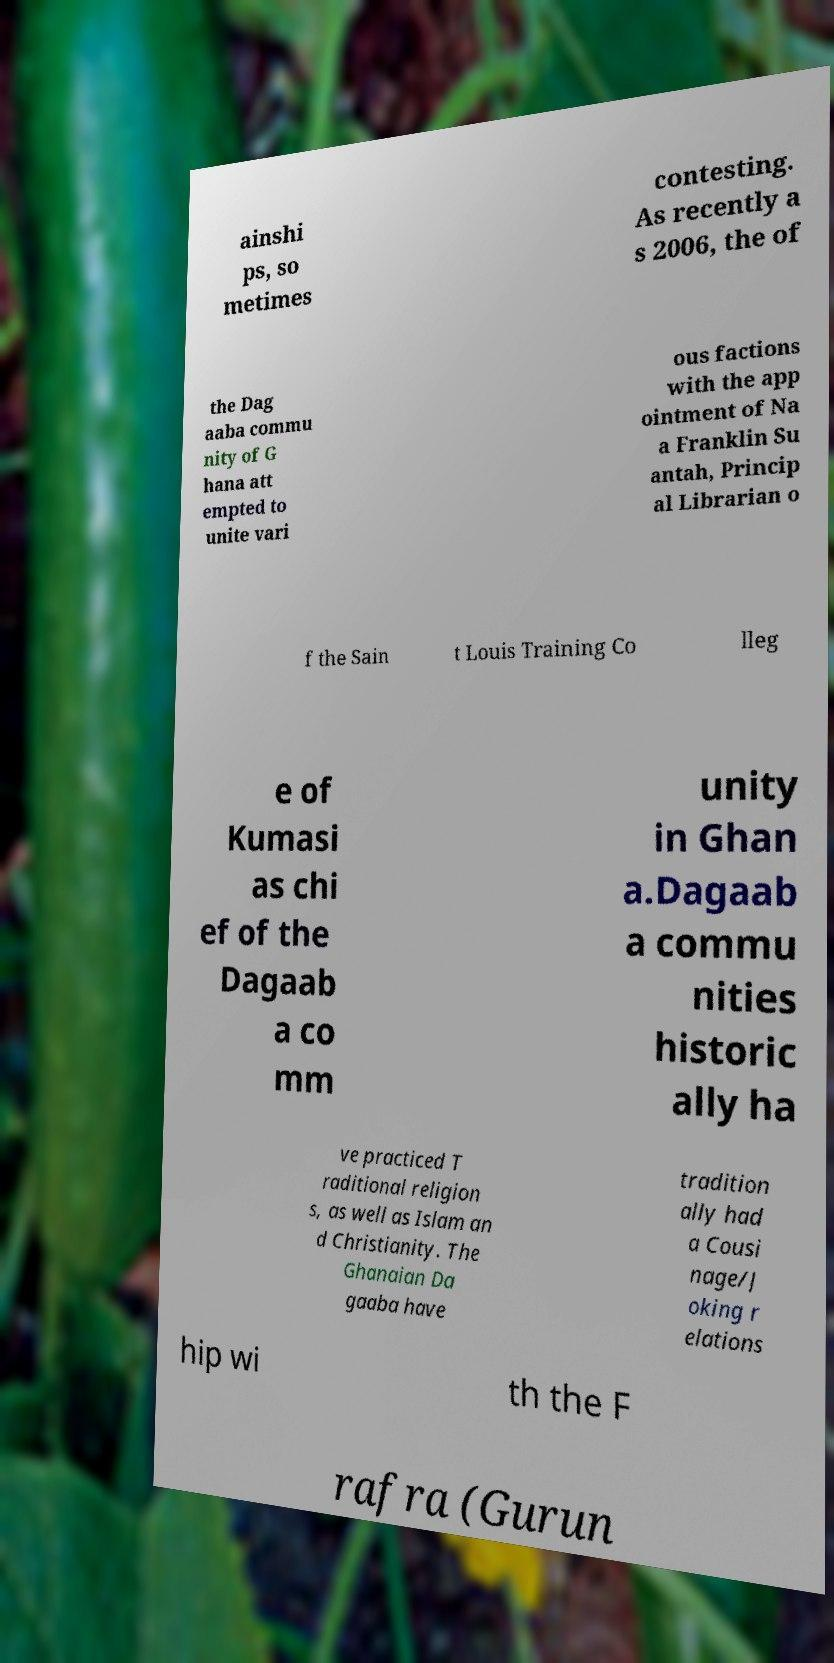Could you assist in decoding the text presented in this image and type it out clearly? ainshi ps, so metimes contesting. As recently a s 2006, the of the Dag aaba commu nity of G hana att empted to unite vari ous factions with the app ointment of Na a Franklin Su antah, Princip al Librarian o f the Sain t Louis Training Co lleg e of Kumasi as chi ef of the Dagaab a co mm unity in Ghan a.Dagaab a commu nities historic ally ha ve practiced T raditional religion s, as well as Islam an d Christianity. The Ghanaian Da gaaba have tradition ally had a Cousi nage/J oking r elations hip wi th the F rafra (Gurun 